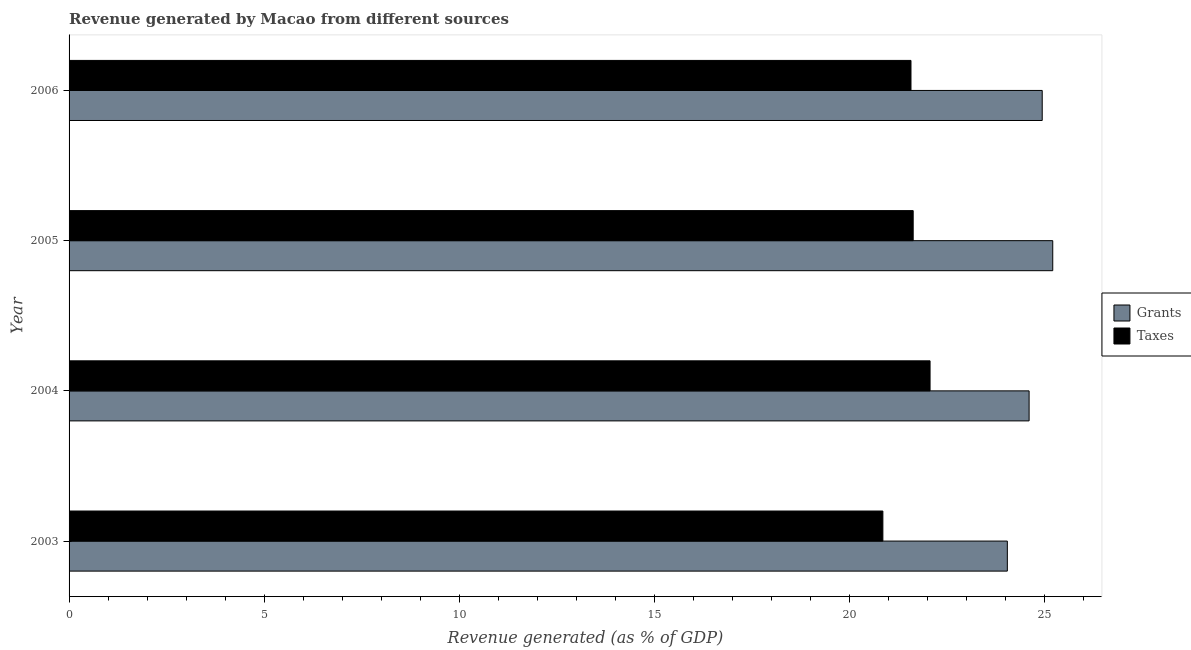How many different coloured bars are there?
Your answer should be compact. 2. How many groups of bars are there?
Provide a short and direct response. 4. How many bars are there on the 4th tick from the top?
Your answer should be compact. 2. How many bars are there on the 2nd tick from the bottom?
Your answer should be compact. 2. What is the label of the 4th group of bars from the top?
Make the answer very short. 2003. What is the revenue generated by grants in 2003?
Keep it short and to the point. 24.05. Across all years, what is the maximum revenue generated by grants?
Provide a succinct answer. 25.21. Across all years, what is the minimum revenue generated by grants?
Offer a terse response. 24.05. What is the total revenue generated by grants in the graph?
Your answer should be compact. 98.8. What is the difference between the revenue generated by grants in 2004 and that in 2006?
Keep it short and to the point. -0.34. What is the difference between the revenue generated by grants in 2004 and the revenue generated by taxes in 2005?
Provide a short and direct response. 2.97. What is the average revenue generated by taxes per year?
Make the answer very short. 21.53. In the year 2004, what is the difference between the revenue generated by grants and revenue generated by taxes?
Provide a short and direct response. 2.54. In how many years, is the revenue generated by grants greater than 1 %?
Give a very brief answer. 4. What is the ratio of the revenue generated by grants in 2004 to that in 2005?
Your response must be concise. 0.98. Is the difference between the revenue generated by taxes in 2005 and 2006 greater than the difference between the revenue generated by grants in 2005 and 2006?
Make the answer very short. No. What is the difference between the highest and the second highest revenue generated by taxes?
Provide a short and direct response. 0.43. What is the difference between the highest and the lowest revenue generated by taxes?
Ensure brevity in your answer.  1.21. Is the sum of the revenue generated by taxes in 2004 and 2005 greater than the maximum revenue generated by grants across all years?
Ensure brevity in your answer.  Yes. What does the 1st bar from the top in 2003 represents?
Provide a succinct answer. Taxes. What does the 1st bar from the bottom in 2006 represents?
Your response must be concise. Grants. How many years are there in the graph?
Provide a short and direct response. 4. Does the graph contain any zero values?
Your answer should be compact. No. Does the graph contain grids?
Your answer should be very brief. No. How many legend labels are there?
Offer a terse response. 2. How are the legend labels stacked?
Offer a very short reply. Vertical. What is the title of the graph?
Provide a short and direct response. Revenue generated by Macao from different sources. What is the label or title of the X-axis?
Keep it short and to the point. Revenue generated (as % of GDP). What is the label or title of the Y-axis?
Your answer should be very brief. Year. What is the Revenue generated (as % of GDP) in Grants in 2003?
Give a very brief answer. 24.05. What is the Revenue generated (as % of GDP) in Taxes in 2003?
Offer a terse response. 20.86. What is the Revenue generated (as % of GDP) of Grants in 2004?
Your answer should be very brief. 24.61. What is the Revenue generated (as % of GDP) of Taxes in 2004?
Keep it short and to the point. 22.07. What is the Revenue generated (as % of GDP) of Grants in 2005?
Give a very brief answer. 25.21. What is the Revenue generated (as % of GDP) of Taxes in 2005?
Offer a very short reply. 21.63. What is the Revenue generated (as % of GDP) of Grants in 2006?
Provide a short and direct response. 24.94. What is the Revenue generated (as % of GDP) of Taxes in 2006?
Your answer should be compact. 21.58. Across all years, what is the maximum Revenue generated (as % of GDP) of Grants?
Your answer should be compact. 25.21. Across all years, what is the maximum Revenue generated (as % of GDP) of Taxes?
Ensure brevity in your answer.  22.07. Across all years, what is the minimum Revenue generated (as % of GDP) in Grants?
Provide a succinct answer. 24.05. Across all years, what is the minimum Revenue generated (as % of GDP) of Taxes?
Keep it short and to the point. 20.86. What is the total Revenue generated (as % of GDP) in Grants in the graph?
Ensure brevity in your answer.  98.8. What is the total Revenue generated (as % of GDP) of Taxes in the graph?
Provide a succinct answer. 86.14. What is the difference between the Revenue generated (as % of GDP) of Grants in 2003 and that in 2004?
Offer a very short reply. -0.56. What is the difference between the Revenue generated (as % of GDP) of Taxes in 2003 and that in 2004?
Provide a succinct answer. -1.21. What is the difference between the Revenue generated (as % of GDP) of Grants in 2003 and that in 2005?
Provide a short and direct response. -1.16. What is the difference between the Revenue generated (as % of GDP) of Taxes in 2003 and that in 2005?
Your answer should be compact. -0.78. What is the difference between the Revenue generated (as % of GDP) of Grants in 2003 and that in 2006?
Provide a succinct answer. -0.89. What is the difference between the Revenue generated (as % of GDP) of Taxes in 2003 and that in 2006?
Offer a very short reply. -0.72. What is the difference between the Revenue generated (as % of GDP) of Grants in 2004 and that in 2005?
Your answer should be very brief. -0.61. What is the difference between the Revenue generated (as % of GDP) of Taxes in 2004 and that in 2005?
Offer a very short reply. 0.43. What is the difference between the Revenue generated (as % of GDP) of Grants in 2004 and that in 2006?
Your answer should be very brief. -0.34. What is the difference between the Revenue generated (as % of GDP) in Taxes in 2004 and that in 2006?
Give a very brief answer. 0.49. What is the difference between the Revenue generated (as % of GDP) of Grants in 2005 and that in 2006?
Offer a very short reply. 0.27. What is the difference between the Revenue generated (as % of GDP) in Taxes in 2005 and that in 2006?
Ensure brevity in your answer.  0.06. What is the difference between the Revenue generated (as % of GDP) in Grants in 2003 and the Revenue generated (as % of GDP) in Taxes in 2004?
Your answer should be compact. 1.98. What is the difference between the Revenue generated (as % of GDP) in Grants in 2003 and the Revenue generated (as % of GDP) in Taxes in 2005?
Make the answer very short. 2.41. What is the difference between the Revenue generated (as % of GDP) in Grants in 2003 and the Revenue generated (as % of GDP) in Taxes in 2006?
Your answer should be compact. 2.47. What is the difference between the Revenue generated (as % of GDP) of Grants in 2004 and the Revenue generated (as % of GDP) of Taxes in 2005?
Give a very brief answer. 2.97. What is the difference between the Revenue generated (as % of GDP) in Grants in 2004 and the Revenue generated (as % of GDP) in Taxes in 2006?
Offer a very short reply. 3.03. What is the difference between the Revenue generated (as % of GDP) of Grants in 2005 and the Revenue generated (as % of GDP) of Taxes in 2006?
Keep it short and to the point. 3.63. What is the average Revenue generated (as % of GDP) of Grants per year?
Give a very brief answer. 24.7. What is the average Revenue generated (as % of GDP) in Taxes per year?
Offer a very short reply. 21.53. In the year 2003, what is the difference between the Revenue generated (as % of GDP) in Grants and Revenue generated (as % of GDP) in Taxes?
Offer a very short reply. 3.19. In the year 2004, what is the difference between the Revenue generated (as % of GDP) of Grants and Revenue generated (as % of GDP) of Taxes?
Your answer should be very brief. 2.54. In the year 2005, what is the difference between the Revenue generated (as % of GDP) in Grants and Revenue generated (as % of GDP) in Taxes?
Keep it short and to the point. 3.58. In the year 2006, what is the difference between the Revenue generated (as % of GDP) of Grants and Revenue generated (as % of GDP) of Taxes?
Your response must be concise. 3.36. What is the ratio of the Revenue generated (as % of GDP) of Grants in 2003 to that in 2004?
Give a very brief answer. 0.98. What is the ratio of the Revenue generated (as % of GDP) of Taxes in 2003 to that in 2004?
Your response must be concise. 0.95. What is the ratio of the Revenue generated (as % of GDP) in Grants in 2003 to that in 2005?
Your answer should be very brief. 0.95. What is the ratio of the Revenue generated (as % of GDP) of Taxes in 2003 to that in 2005?
Keep it short and to the point. 0.96. What is the ratio of the Revenue generated (as % of GDP) in Grants in 2003 to that in 2006?
Ensure brevity in your answer.  0.96. What is the ratio of the Revenue generated (as % of GDP) of Taxes in 2003 to that in 2006?
Ensure brevity in your answer.  0.97. What is the ratio of the Revenue generated (as % of GDP) of Grants in 2004 to that in 2005?
Your answer should be compact. 0.98. What is the ratio of the Revenue generated (as % of GDP) of Taxes in 2004 to that in 2005?
Provide a short and direct response. 1.02. What is the ratio of the Revenue generated (as % of GDP) of Grants in 2004 to that in 2006?
Your answer should be compact. 0.99. What is the ratio of the Revenue generated (as % of GDP) in Taxes in 2004 to that in 2006?
Provide a short and direct response. 1.02. What is the ratio of the Revenue generated (as % of GDP) in Grants in 2005 to that in 2006?
Keep it short and to the point. 1.01. What is the difference between the highest and the second highest Revenue generated (as % of GDP) in Grants?
Provide a short and direct response. 0.27. What is the difference between the highest and the second highest Revenue generated (as % of GDP) of Taxes?
Provide a succinct answer. 0.43. What is the difference between the highest and the lowest Revenue generated (as % of GDP) of Grants?
Your answer should be very brief. 1.16. What is the difference between the highest and the lowest Revenue generated (as % of GDP) of Taxes?
Your answer should be compact. 1.21. 